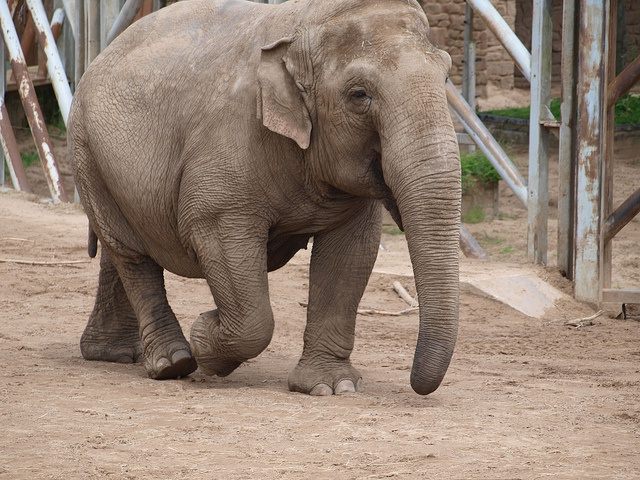Describe the objects in this image and their specific colors. I can see a elephant in lightgray, gray, darkgray, and black tones in this image. 